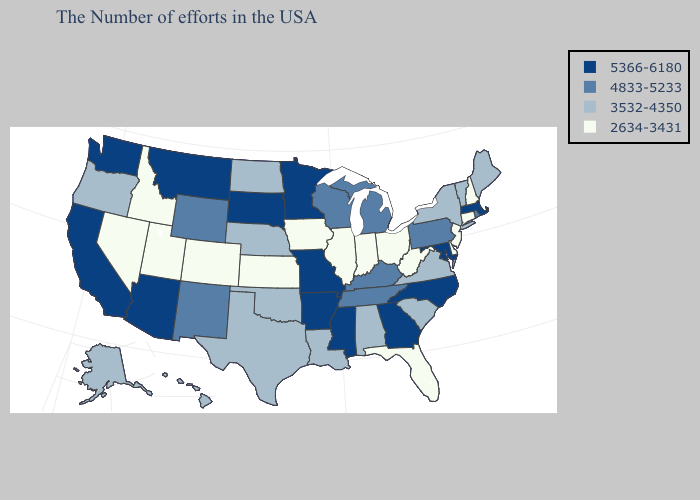Does the map have missing data?
Be succinct. No. What is the value of Mississippi?
Answer briefly. 5366-6180. What is the value of Iowa?
Concise answer only. 2634-3431. Name the states that have a value in the range 3532-4350?
Short answer required. Maine, Vermont, New York, Virginia, South Carolina, Alabama, Louisiana, Nebraska, Oklahoma, Texas, North Dakota, Oregon, Alaska, Hawaii. Name the states that have a value in the range 5366-6180?
Short answer required. Massachusetts, Maryland, North Carolina, Georgia, Mississippi, Missouri, Arkansas, Minnesota, South Dakota, Montana, Arizona, California, Washington. Name the states that have a value in the range 5366-6180?
Keep it brief. Massachusetts, Maryland, North Carolina, Georgia, Mississippi, Missouri, Arkansas, Minnesota, South Dakota, Montana, Arizona, California, Washington. Name the states that have a value in the range 3532-4350?
Answer briefly. Maine, Vermont, New York, Virginia, South Carolina, Alabama, Louisiana, Nebraska, Oklahoma, Texas, North Dakota, Oregon, Alaska, Hawaii. What is the lowest value in the USA?
Quick response, please. 2634-3431. Among the states that border Washington , does Oregon have the lowest value?
Quick response, please. No. Name the states that have a value in the range 3532-4350?
Write a very short answer. Maine, Vermont, New York, Virginia, South Carolina, Alabama, Louisiana, Nebraska, Oklahoma, Texas, North Dakota, Oregon, Alaska, Hawaii. How many symbols are there in the legend?
Concise answer only. 4. What is the value of Illinois?
Keep it brief. 2634-3431. Is the legend a continuous bar?
Quick response, please. No. Which states have the lowest value in the West?
Quick response, please. Colorado, Utah, Idaho, Nevada. What is the value of Hawaii?
Answer briefly. 3532-4350. 